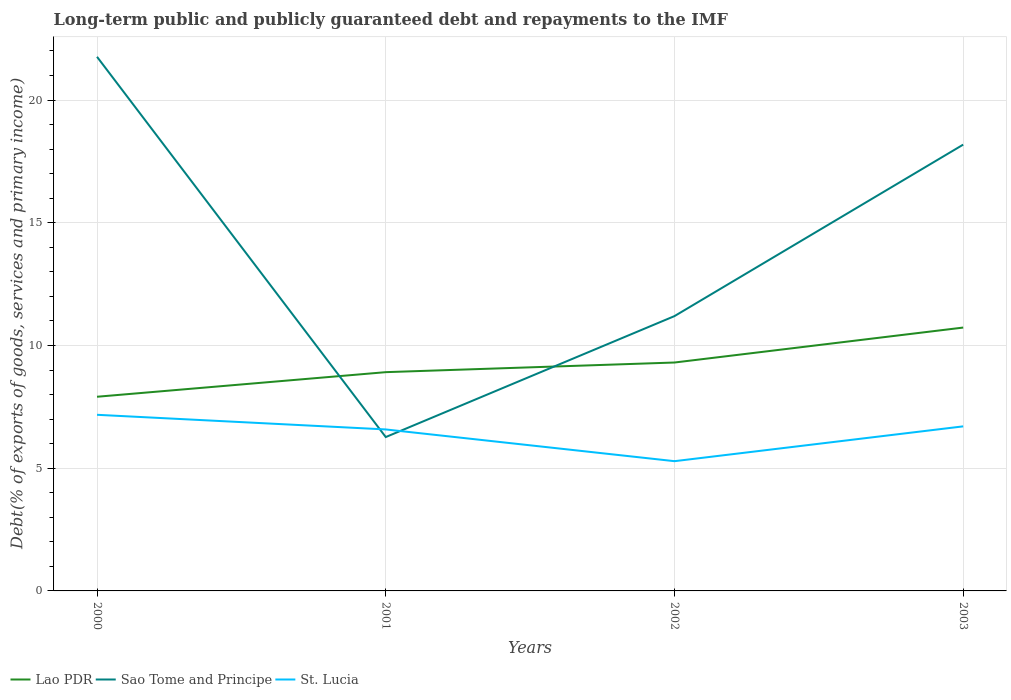Does the line corresponding to St. Lucia intersect with the line corresponding to Lao PDR?
Give a very brief answer. No. Across all years, what is the maximum debt and repayments in St. Lucia?
Your answer should be very brief. 5.29. What is the total debt and repayments in Sao Tome and Principe in the graph?
Ensure brevity in your answer.  15.49. What is the difference between the highest and the second highest debt and repayments in St. Lucia?
Give a very brief answer. 1.89. What is the difference between the highest and the lowest debt and repayments in Sao Tome and Principe?
Your answer should be compact. 2. How many lines are there?
Keep it short and to the point. 3. Are the values on the major ticks of Y-axis written in scientific E-notation?
Provide a succinct answer. No. Does the graph contain any zero values?
Offer a very short reply. No. Does the graph contain grids?
Your answer should be very brief. Yes. Where does the legend appear in the graph?
Ensure brevity in your answer.  Bottom left. What is the title of the graph?
Make the answer very short. Long-term public and publicly guaranteed debt and repayments to the IMF. What is the label or title of the Y-axis?
Offer a terse response. Debt(% of exports of goods, services and primary income). What is the Debt(% of exports of goods, services and primary income) of Lao PDR in 2000?
Give a very brief answer. 7.91. What is the Debt(% of exports of goods, services and primary income) in Sao Tome and Principe in 2000?
Make the answer very short. 21.76. What is the Debt(% of exports of goods, services and primary income) in St. Lucia in 2000?
Offer a very short reply. 7.18. What is the Debt(% of exports of goods, services and primary income) in Lao PDR in 2001?
Provide a succinct answer. 8.91. What is the Debt(% of exports of goods, services and primary income) of Sao Tome and Principe in 2001?
Your response must be concise. 6.27. What is the Debt(% of exports of goods, services and primary income) in St. Lucia in 2001?
Give a very brief answer. 6.58. What is the Debt(% of exports of goods, services and primary income) of Lao PDR in 2002?
Ensure brevity in your answer.  9.31. What is the Debt(% of exports of goods, services and primary income) in Sao Tome and Principe in 2002?
Keep it short and to the point. 11.2. What is the Debt(% of exports of goods, services and primary income) of St. Lucia in 2002?
Keep it short and to the point. 5.29. What is the Debt(% of exports of goods, services and primary income) of Lao PDR in 2003?
Provide a succinct answer. 10.73. What is the Debt(% of exports of goods, services and primary income) of Sao Tome and Principe in 2003?
Your answer should be compact. 18.18. What is the Debt(% of exports of goods, services and primary income) in St. Lucia in 2003?
Ensure brevity in your answer.  6.7. Across all years, what is the maximum Debt(% of exports of goods, services and primary income) in Lao PDR?
Make the answer very short. 10.73. Across all years, what is the maximum Debt(% of exports of goods, services and primary income) in Sao Tome and Principe?
Keep it short and to the point. 21.76. Across all years, what is the maximum Debt(% of exports of goods, services and primary income) in St. Lucia?
Make the answer very short. 7.18. Across all years, what is the minimum Debt(% of exports of goods, services and primary income) of Lao PDR?
Offer a very short reply. 7.91. Across all years, what is the minimum Debt(% of exports of goods, services and primary income) in Sao Tome and Principe?
Your answer should be very brief. 6.27. Across all years, what is the minimum Debt(% of exports of goods, services and primary income) in St. Lucia?
Give a very brief answer. 5.29. What is the total Debt(% of exports of goods, services and primary income) of Lao PDR in the graph?
Provide a short and direct response. 36.86. What is the total Debt(% of exports of goods, services and primary income) of Sao Tome and Principe in the graph?
Your response must be concise. 57.41. What is the total Debt(% of exports of goods, services and primary income) of St. Lucia in the graph?
Keep it short and to the point. 25.75. What is the difference between the Debt(% of exports of goods, services and primary income) of Lao PDR in 2000 and that in 2001?
Your response must be concise. -1. What is the difference between the Debt(% of exports of goods, services and primary income) in Sao Tome and Principe in 2000 and that in 2001?
Your answer should be compact. 15.49. What is the difference between the Debt(% of exports of goods, services and primary income) in St. Lucia in 2000 and that in 2001?
Ensure brevity in your answer.  0.6. What is the difference between the Debt(% of exports of goods, services and primary income) of Lao PDR in 2000 and that in 2002?
Make the answer very short. -1.39. What is the difference between the Debt(% of exports of goods, services and primary income) of Sao Tome and Principe in 2000 and that in 2002?
Provide a short and direct response. 10.57. What is the difference between the Debt(% of exports of goods, services and primary income) of St. Lucia in 2000 and that in 2002?
Provide a short and direct response. 1.89. What is the difference between the Debt(% of exports of goods, services and primary income) of Lao PDR in 2000 and that in 2003?
Offer a terse response. -2.82. What is the difference between the Debt(% of exports of goods, services and primary income) in Sao Tome and Principe in 2000 and that in 2003?
Offer a very short reply. 3.58. What is the difference between the Debt(% of exports of goods, services and primary income) of St. Lucia in 2000 and that in 2003?
Your answer should be compact. 0.47. What is the difference between the Debt(% of exports of goods, services and primary income) in Lao PDR in 2001 and that in 2002?
Offer a very short reply. -0.39. What is the difference between the Debt(% of exports of goods, services and primary income) in Sao Tome and Principe in 2001 and that in 2002?
Provide a succinct answer. -4.93. What is the difference between the Debt(% of exports of goods, services and primary income) of St. Lucia in 2001 and that in 2002?
Your answer should be compact. 1.29. What is the difference between the Debt(% of exports of goods, services and primary income) in Lao PDR in 2001 and that in 2003?
Offer a terse response. -1.82. What is the difference between the Debt(% of exports of goods, services and primary income) in Sao Tome and Principe in 2001 and that in 2003?
Your answer should be compact. -11.91. What is the difference between the Debt(% of exports of goods, services and primary income) in St. Lucia in 2001 and that in 2003?
Provide a short and direct response. -0.13. What is the difference between the Debt(% of exports of goods, services and primary income) of Lao PDR in 2002 and that in 2003?
Your answer should be compact. -1.42. What is the difference between the Debt(% of exports of goods, services and primary income) in Sao Tome and Principe in 2002 and that in 2003?
Your answer should be very brief. -6.99. What is the difference between the Debt(% of exports of goods, services and primary income) in St. Lucia in 2002 and that in 2003?
Offer a terse response. -1.42. What is the difference between the Debt(% of exports of goods, services and primary income) of Lao PDR in 2000 and the Debt(% of exports of goods, services and primary income) of Sao Tome and Principe in 2001?
Offer a very short reply. 1.64. What is the difference between the Debt(% of exports of goods, services and primary income) in Lao PDR in 2000 and the Debt(% of exports of goods, services and primary income) in St. Lucia in 2001?
Provide a short and direct response. 1.33. What is the difference between the Debt(% of exports of goods, services and primary income) in Sao Tome and Principe in 2000 and the Debt(% of exports of goods, services and primary income) in St. Lucia in 2001?
Provide a succinct answer. 15.18. What is the difference between the Debt(% of exports of goods, services and primary income) of Lao PDR in 2000 and the Debt(% of exports of goods, services and primary income) of Sao Tome and Principe in 2002?
Your answer should be very brief. -3.29. What is the difference between the Debt(% of exports of goods, services and primary income) in Lao PDR in 2000 and the Debt(% of exports of goods, services and primary income) in St. Lucia in 2002?
Give a very brief answer. 2.62. What is the difference between the Debt(% of exports of goods, services and primary income) in Sao Tome and Principe in 2000 and the Debt(% of exports of goods, services and primary income) in St. Lucia in 2002?
Give a very brief answer. 16.48. What is the difference between the Debt(% of exports of goods, services and primary income) in Lao PDR in 2000 and the Debt(% of exports of goods, services and primary income) in Sao Tome and Principe in 2003?
Your response must be concise. -10.27. What is the difference between the Debt(% of exports of goods, services and primary income) in Lao PDR in 2000 and the Debt(% of exports of goods, services and primary income) in St. Lucia in 2003?
Give a very brief answer. 1.21. What is the difference between the Debt(% of exports of goods, services and primary income) of Sao Tome and Principe in 2000 and the Debt(% of exports of goods, services and primary income) of St. Lucia in 2003?
Your response must be concise. 15.06. What is the difference between the Debt(% of exports of goods, services and primary income) in Lao PDR in 2001 and the Debt(% of exports of goods, services and primary income) in Sao Tome and Principe in 2002?
Keep it short and to the point. -2.28. What is the difference between the Debt(% of exports of goods, services and primary income) of Lao PDR in 2001 and the Debt(% of exports of goods, services and primary income) of St. Lucia in 2002?
Keep it short and to the point. 3.63. What is the difference between the Debt(% of exports of goods, services and primary income) in Sao Tome and Principe in 2001 and the Debt(% of exports of goods, services and primary income) in St. Lucia in 2002?
Ensure brevity in your answer.  0.98. What is the difference between the Debt(% of exports of goods, services and primary income) of Lao PDR in 2001 and the Debt(% of exports of goods, services and primary income) of Sao Tome and Principe in 2003?
Make the answer very short. -9.27. What is the difference between the Debt(% of exports of goods, services and primary income) of Lao PDR in 2001 and the Debt(% of exports of goods, services and primary income) of St. Lucia in 2003?
Provide a short and direct response. 2.21. What is the difference between the Debt(% of exports of goods, services and primary income) in Sao Tome and Principe in 2001 and the Debt(% of exports of goods, services and primary income) in St. Lucia in 2003?
Provide a succinct answer. -0.44. What is the difference between the Debt(% of exports of goods, services and primary income) of Lao PDR in 2002 and the Debt(% of exports of goods, services and primary income) of Sao Tome and Principe in 2003?
Keep it short and to the point. -8.88. What is the difference between the Debt(% of exports of goods, services and primary income) of Lao PDR in 2002 and the Debt(% of exports of goods, services and primary income) of St. Lucia in 2003?
Make the answer very short. 2.6. What is the difference between the Debt(% of exports of goods, services and primary income) in Sao Tome and Principe in 2002 and the Debt(% of exports of goods, services and primary income) in St. Lucia in 2003?
Provide a short and direct response. 4.49. What is the average Debt(% of exports of goods, services and primary income) of Lao PDR per year?
Keep it short and to the point. 9.21. What is the average Debt(% of exports of goods, services and primary income) in Sao Tome and Principe per year?
Provide a succinct answer. 14.35. What is the average Debt(% of exports of goods, services and primary income) in St. Lucia per year?
Offer a very short reply. 6.44. In the year 2000, what is the difference between the Debt(% of exports of goods, services and primary income) in Lao PDR and Debt(% of exports of goods, services and primary income) in Sao Tome and Principe?
Provide a succinct answer. -13.85. In the year 2000, what is the difference between the Debt(% of exports of goods, services and primary income) of Lao PDR and Debt(% of exports of goods, services and primary income) of St. Lucia?
Keep it short and to the point. 0.73. In the year 2000, what is the difference between the Debt(% of exports of goods, services and primary income) of Sao Tome and Principe and Debt(% of exports of goods, services and primary income) of St. Lucia?
Provide a succinct answer. 14.59. In the year 2001, what is the difference between the Debt(% of exports of goods, services and primary income) of Lao PDR and Debt(% of exports of goods, services and primary income) of Sao Tome and Principe?
Offer a very short reply. 2.64. In the year 2001, what is the difference between the Debt(% of exports of goods, services and primary income) of Lao PDR and Debt(% of exports of goods, services and primary income) of St. Lucia?
Your response must be concise. 2.33. In the year 2001, what is the difference between the Debt(% of exports of goods, services and primary income) in Sao Tome and Principe and Debt(% of exports of goods, services and primary income) in St. Lucia?
Keep it short and to the point. -0.31. In the year 2002, what is the difference between the Debt(% of exports of goods, services and primary income) of Lao PDR and Debt(% of exports of goods, services and primary income) of Sao Tome and Principe?
Your answer should be very brief. -1.89. In the year 2002, what is the difference between the Debt(% of exports of goods, services and primary income) in Lao PDR and Debt(% of exports of goods, services and primary income) in St. Lucia?
Your response must be concise. 4.02. In the year 2002, what is the difference between the Debt(% of exports of goods, services and primary income) in Sao Tome and Principe and Debt(% of exports of goods, services and primary income) in St. Lucia?
Your answer should be very brief. 5.91. In the year 2003, what is the difference between the Debt(% of exports of goods, services and primary income) of Lao PDR and Debt(% of exports of goods, services and primary income) of Sao Tome and Principe?
Provide a short and direct response. -7.45. In the year 2003, what is the difference between the Debt(% of exports of goods, services and primary income) of Lao PDR and Debt(% of exports of goods, services and primary income) of St. Lucia?
Keep it short and to the point. 4.03. In the year 2003, what is the difference between the Debt(% of exports of goods, services and primary income) in Sao Tome and Principe and Debt(% of exports of goods, services and primary income) in St. Lucia?
Give a very brief answer. 11.48. What is the ratio of the Debt(% of exports of goods, services and primary income) of Lao PDR in 2000 to that in 2001?
Keep it short and to the point. 0.89. What is the ratio of the Debt(% of exports of goods, services and primary income) in Sao Tome and Principe in 2000 to that in 2001?
Your response must be concise. 3.47. What is the ratio of the Debt(% of exports of goods, services and primary income) of St. Lucia in 2000 to that in 2001?
Provide a short and direct response. 1.09. What is the ratio of the Debt(% of exports of goods, services and primary income) in Lao PDR in 2000 to that in 2002?
Provide a succinct answer. 0.85. What is the ratio of the Debt(% of exports of goods, services and primary income) in Sao Tome and Principe in 2000 to that in 2002?
Your response must be concise. 1.94. What is the ratio of the Debt(% of exports of goods, services and primary income) in St. Lucia in 2000 to that in 2002?
Ensure brevity in your answer.  1.36. What is the ratio of the Debt(% of exports of goods, services and primary income) of Lao PDR in 2000 to that in 2003?
Your answer should be very brief. 0.74. What is the ratio of the Debt(% of exports of goods, services and primary income) of Sao Tome and Principe in 2000 to that in 2003?
Your answer should be very brief. 1.2. What is the ratio of the Debt(% of exports of goods, services and primary income) in St. Lucia in 2000 to that in 2003?
Offer a terse response. 1.07. What is the ratio of the Debt(% of exports of goods, services and primary income) in Lao PDR in 2001 to that in 2002?
Keep it short and to the point. 0.96. What is the ratio of the Debt(% of exports of goods, services and primary income) in Sao Tome and Principe in 2001 to that in 2002?
Keep it short and to the point. 0.56. What is the ratio of the Debt(% of exports of goods, services and primary income) of St. Lucia in 2001 to that in 2002?
Give a very brief answer. 1.24. What is the ratio of the Debt(% of exports of goods, services and primary income) in Lao PDR in 2001 to that in 2003?
Provide a short and direct response. 0.83. What is the ratio of the Debt(% of exports of goods, services and primary income) of Sao Tome and Principe in 2001 to that in 2003?
Keep it short and to the point. 0.34. What is the ratio of the Debt(% of exports of goods, services and primary income) of St. Lucia in 2001 to that in 2003?
Your response must be concise. 0.98. What is the ratio of the Debt(% of exports of goods, services and primary income) of Lao PDR in 2002 to that in 2003?
Keep it short and to the point. 0.87. What is the ratio of the Debt(% of exports of goods, services and primary income) of Sao Tome and Principe in 2002 to that in 2003?
Offer a very short reply. 0.62. What is the ratio of the Debt(% of exports of goods, services and primary income) of St. Lucia in 2002 to that in 2003?
Your answer should be very brief. 0.79. What is the difference between the highest and the second highest Debt(% of exports of goods, services and primary income) in Lao PDR?
Your answer should be compact. 1.42. What is the difference between the highest and the second highest Debt(% of exports of goods, services and primary income) of Sao Tome and Principe?
Your answer should be compact. 3.58. What is the difference between the highest and the second highest Debt(% of exports of goods, services and primary income) of St. Lucia?
Provide a short and direct response. 0.47. What is the difference between the highest and the lowest Debt(% of exports of goods, services and primary income) of Lao PDR?
Your response must be concise. 2.82. What is the difference between the highest and the lowest Debt(% of exports of goods, services and primary income) of Sao Tome and Principe?
Ensure brevity in your answer.  15.49. What is the difference between the highest and the lowest Debt(% of exports of goods, services and primary income) in St. Lucia?
Your answer should be compact. 1.89. 